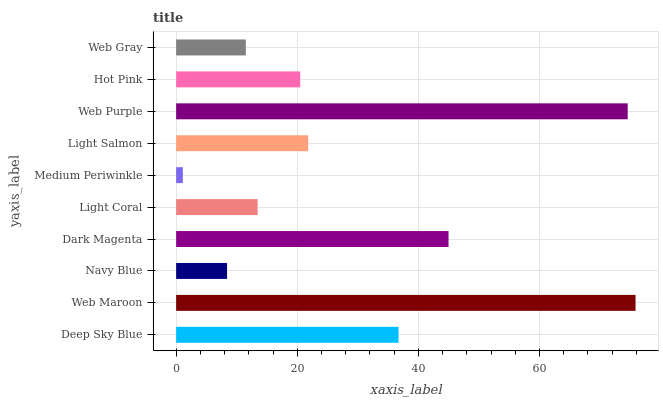Is Medium Periwinkle the minimum?
Answer yes or no. Yes. Is Web Maroon the maximum?
Answer yes or no. Yes. Is Navy Blue the minimum?
Answer yes or no. No. Is Navy Blue the maximum?
Answer yes or no. No. Is Web Maroon greater than Navy Blue?
Answer yes or no. Yes. Is Navy Blue less than Web Maroon?
Answer yes or no. Yes. Is Navy Blue greater than Web Maroon?
Answer yes or no. No. Is Web Maroon less than Navy Blue?
Answer yes or no. No. Is Light Salmon the high median?
Answer yes or no. Yes. Is Hot Pink the low median?
Answer yes or no. Yes. Is Light Coral the high median?
Answer yes or no. No. Is Dark Magenta the low median?
Answer yes or no. No. 